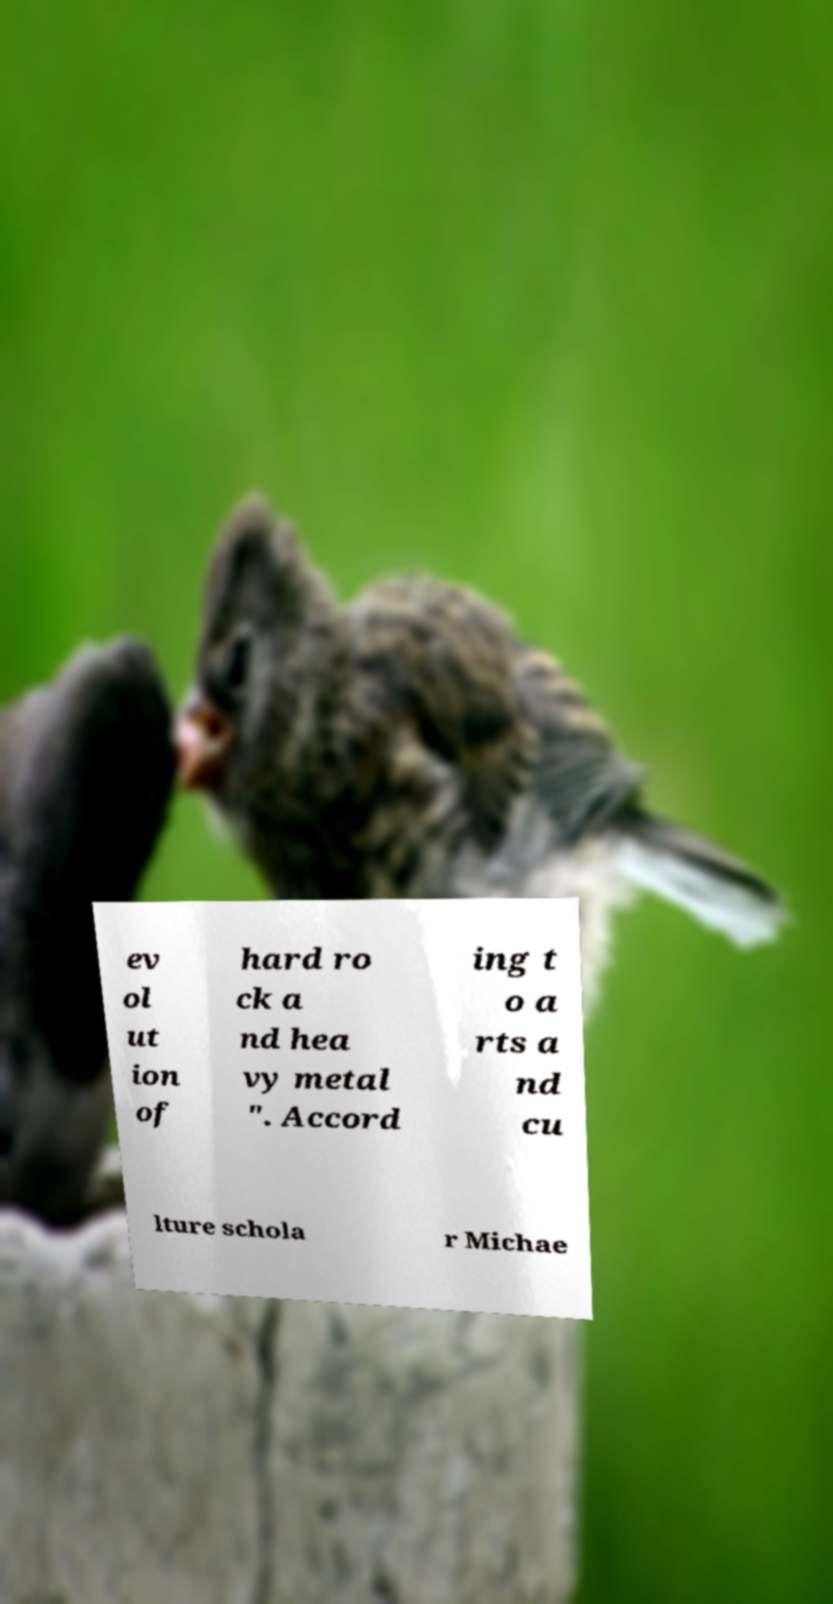Please read and relay the text visible in this image. What does it say? ev ol ut ion of hard ro ck a nd hea vy metal ". Accord ing t o a rts a nd cu lture schola r Michae 